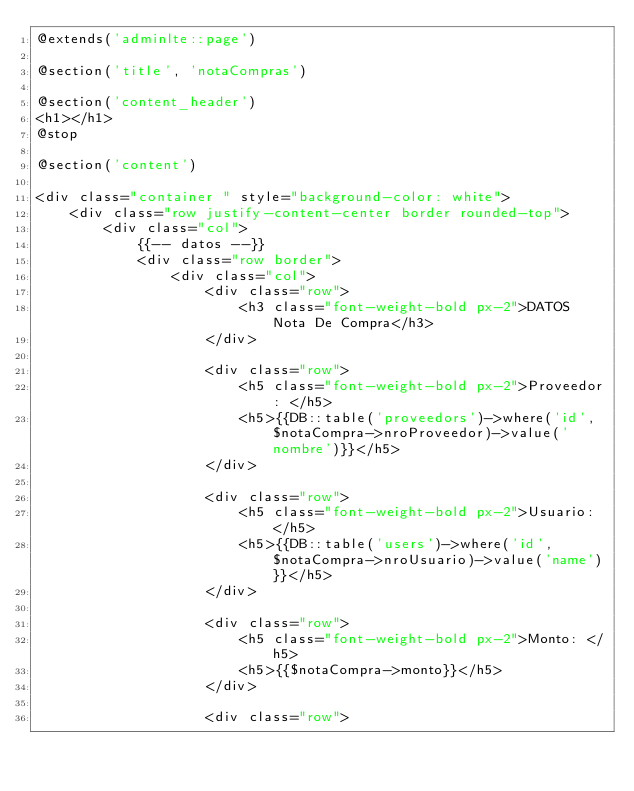<code> <loc_0><loc_0><loc_500><loc_500><_PHP_>@extends('adminlte::page')

@section('title', 'notaCompras')

@section('content_header')
<h1></h1>
@stop

@section('content')

<div class="container " style="background-color: white">
    <div class="row justify-content-center border rounded-top">
        <div class="col">
            {{-- datos --}}
            <div class="row border"> 
                <div class="col">
                    <div class="row">
                        <h3 class="font-weight-bold px-2">DATOS Nota De Compra</h3>
                    </div>
                    
                    <div class="row">
                        <h5 class="font-weight-bold px-2">Proveedor: </h5>
                        <h5>{{DB::table('proveedors')->where('id',$notaCompra->nroProveedor)->value('nombre')}}</h5>
                    </div>

                    <div class="row">
                        <h5 class="font-weight-bold px-2">Usuario: </h5>
                        <h5>{{DB::table('users')->where('id',$notaCompra->nroUsuario)->value('name')}}</h5>
                    </div>

                    <div class="row">
                        <h5 class="font-weight-bold px-2">Monto: </h5>
                        <h5>{{$notaCompra->monto}}</h5>
                    </div>

                    <div class="row"></code> 